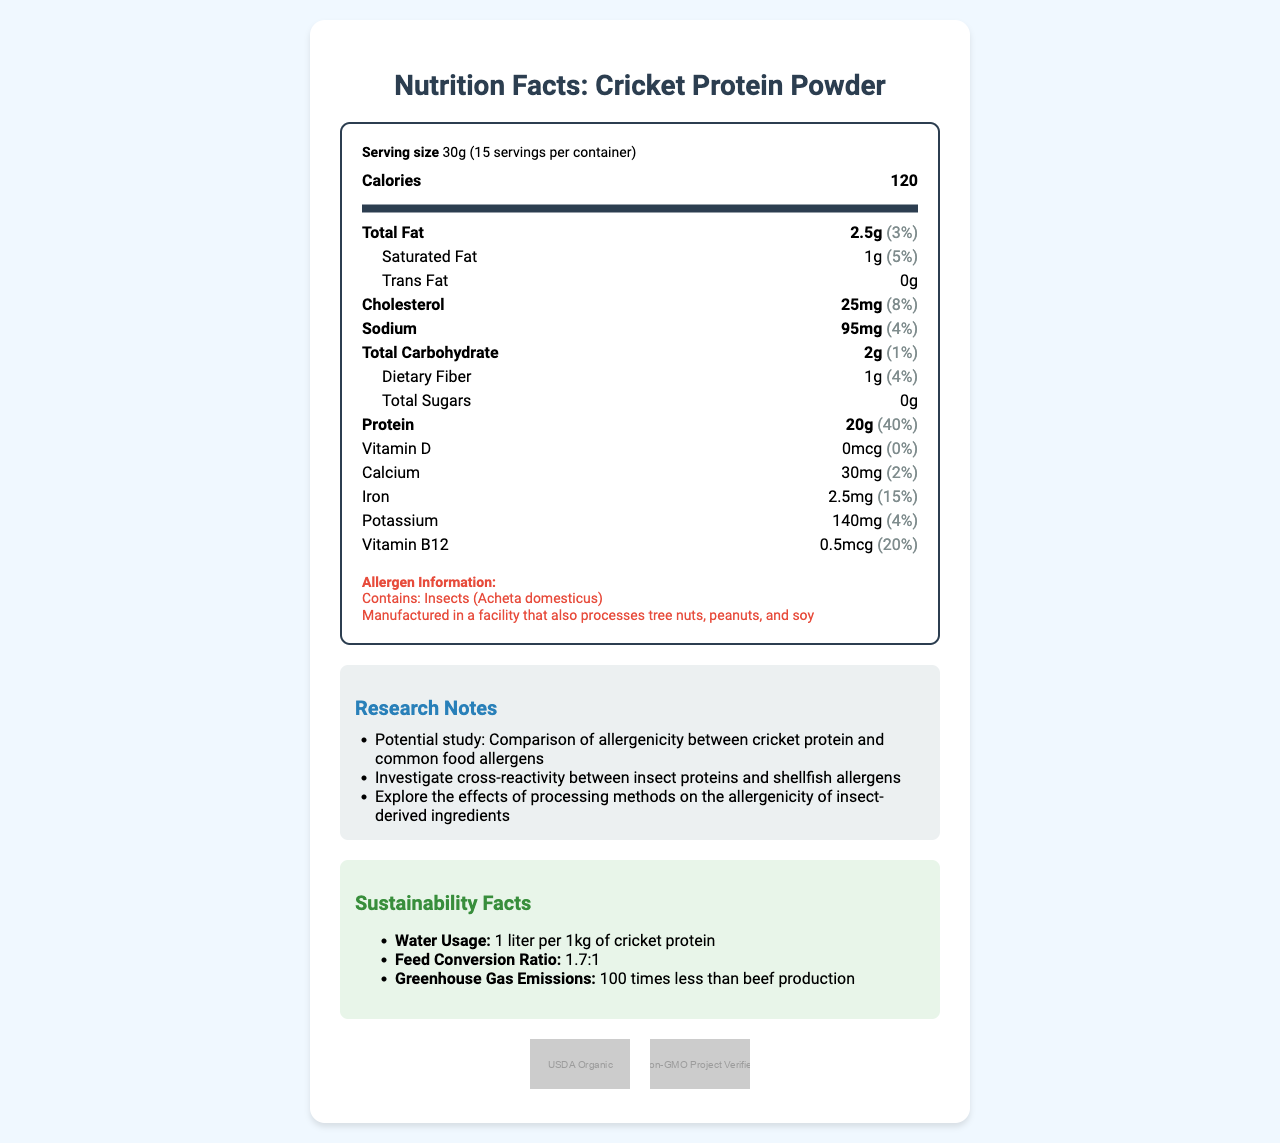what is the serving size? The serving size is explicitly stated in the document as "Serving size 30g".
Answer: 30g how many servings are in the container? The document indicates that there are 15 servings per container.
Answer: 15 what allergens should consumers be aware of in this product? The allergen information section lists the allergens as insects (Acheta domesticus) and notes that the product is manufactured in a facility that processes tree nuts, peanuts, and soy.
Answer: Insects (Acheta domesticus), tree nuts, peanuts, and soy how much protein is in one serving of this product? The document states that one serving contains 20g of protein.
Answer: 20g what is the daily value percentage for protein in this product? The document mentions that the daily value percentage for protein is 40%.
Answer: 40% which of the following is NOT an allergen listed for the product? A. Insects B. Gluten C. Tree Nuts D. Peanuts Gluten is not listed as an allergen in the document.
Answer: B how much calcium is in the product? A. 30mg B. 40mg C. 20mg D. 50mg The document states that the product contains 30mg of calcium.
Answer: A does this product contain trans fat? The document clearly states that the product contains 0g of trans fat.
Answer: No what are the sustainability benefits of this product? The document lists sustainability facts, mentioning low water usage (1 liter per 1kg of cricket protein), an efficient feed conversion ratio (1.7:1), and significantly lower greenhouse gas emissions (100 times less than beef production).
Answer: Potentially lower environmental impact in terms of water usage, feed conversion, and greenhouse gas emissions how does this product compare to common food allergens regarding allergenicity? The document hints at potential research into allergenicity but does not provide comparative data or conclusions.
Answer: Cannot be determined describe the main idea of the document The document is a detailed presentation about Cricket Protein Powder, including nutrition facts, allergen information, potential research notes for allergenicity, sustainability benefits, and certifications like USDA Organic and Non-GMO Project Verified.
Answer: The document provides the nutritional information, allergen details, research notes, sustainability facts, and certifications for Cricket Protein Powder. 